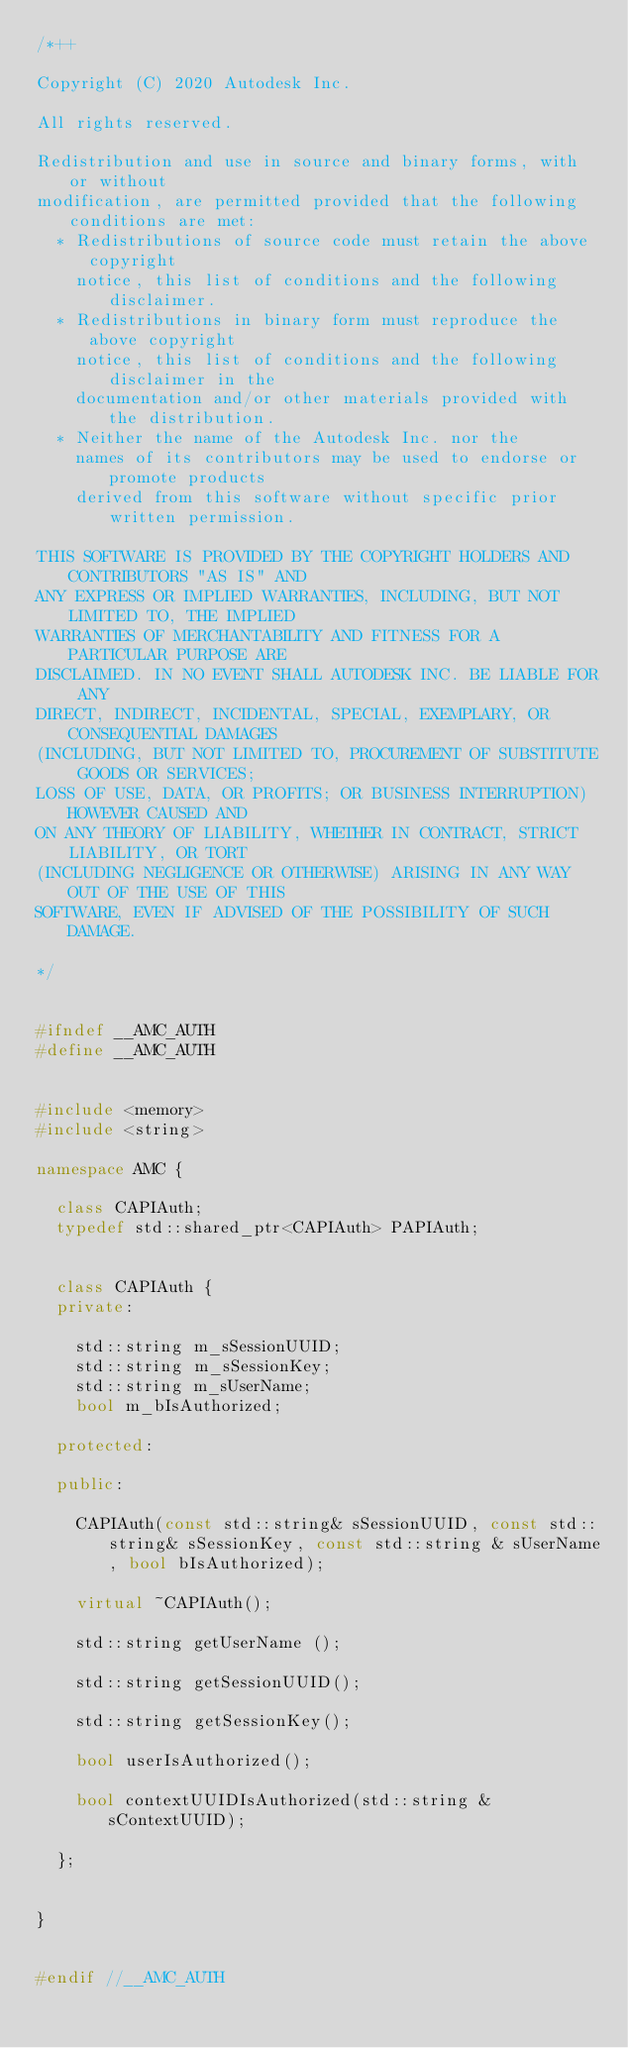Convert code to text. <code><loc_0><loc_0><loc_500><loc_500><_C++_>/*++

Copyright (C) 2020 Autodesk Inc.

All rights reserved.

Redistribution and use in source and binary forms, with or without
modification, are permitted provided that the following conditions are met:
	* Redistributions of source code must retain the above copyright
	  notice, this list of conditions and the following disclaimer.
	* Redistributions in binary form must reproduce the above copyright
	  notice, this list of conditions and the following disclaimer in the
	  documentation and/or other materials provided with the distribution.
	* Neither the name of the Autodesk Inc. nor the
	  names of its contributors may be used to endorse or promote products
	  derived from this software without specific prior written permission.

THIS SOFTWARE IS PROVIDED BY THE COPYRIGHT HOLDERS AND CONTRIBUTORS "AS IS" AND
ANY EXPRESS OR IMPLIED WARRANTIES, INCLUDING, BUT NOT LIMITED TO, THE IMPLIED
WARRANTIES OF MERCHANTABILITY AND FITNESS FOR A PARTICULAR PURPOSE ARE
DISCLAIMED. IN NO EVENT SHALL AUTODESK INC. BE LIABLE FOR ANY
DIRECT, INDIRECT, INCIDENTAL, SPECIAL, EXEMPLARY, OR CONSEQUENTIAL DAMAGES
(INCLUDING, BUT NOT LIMITED TO, PROCUREMENT OF SUBSTITUTE GOODS OR SERVICES;
LOSS OF USE, DATA, OR PROFITS; OR BUSINESS INTERRUPTION) HOWEVER CAUSED AND
ON ANY THEORY OF LIABILITY, WHETHER IN CONTRACT, STRICT LIABILITY, OR TORT
(INCLUDING NEGLIGENCE OR OTHERWISE) ARISING IN ANY WAY OUT OF THE USE OF THIS
SOFTWARE, EVEN IF ADVISED OF THE POSSIBILITY OF SUCH DAMAGE.

*/


#ifndef __AMC_AUTH
#define __AMC_AUTH


#include <memory>
#include <string>

namespace AMC {

	class CAPIAuth;
	typedef std::shared_ptr<CAPIAuth> PAPIAuth;
	

	class CAPIAuth {
	private:

		std::string m_sSessionUUID;
		std::string m_sSessionKey;
		std::string m_sUserName;
		bool m_bIsAuthorized;

	protected:

	public:

		CAPIAuth(const std::string& sSessionUUID, const std::string& sSessionKey, const std::string & sUserName, bool bIsAuthorized);

		virtual ~CAPIAuth();
		
		std::string getUserName ();

		std::string getSessionUUID();

		std::string getSessionKey();

		bool userIsAuthorized();

		bool contextUUIDIsAuthorized(std::string & sContextUUID);
								
	};

	
}


#endif //__AMC_AUTH

</code> 